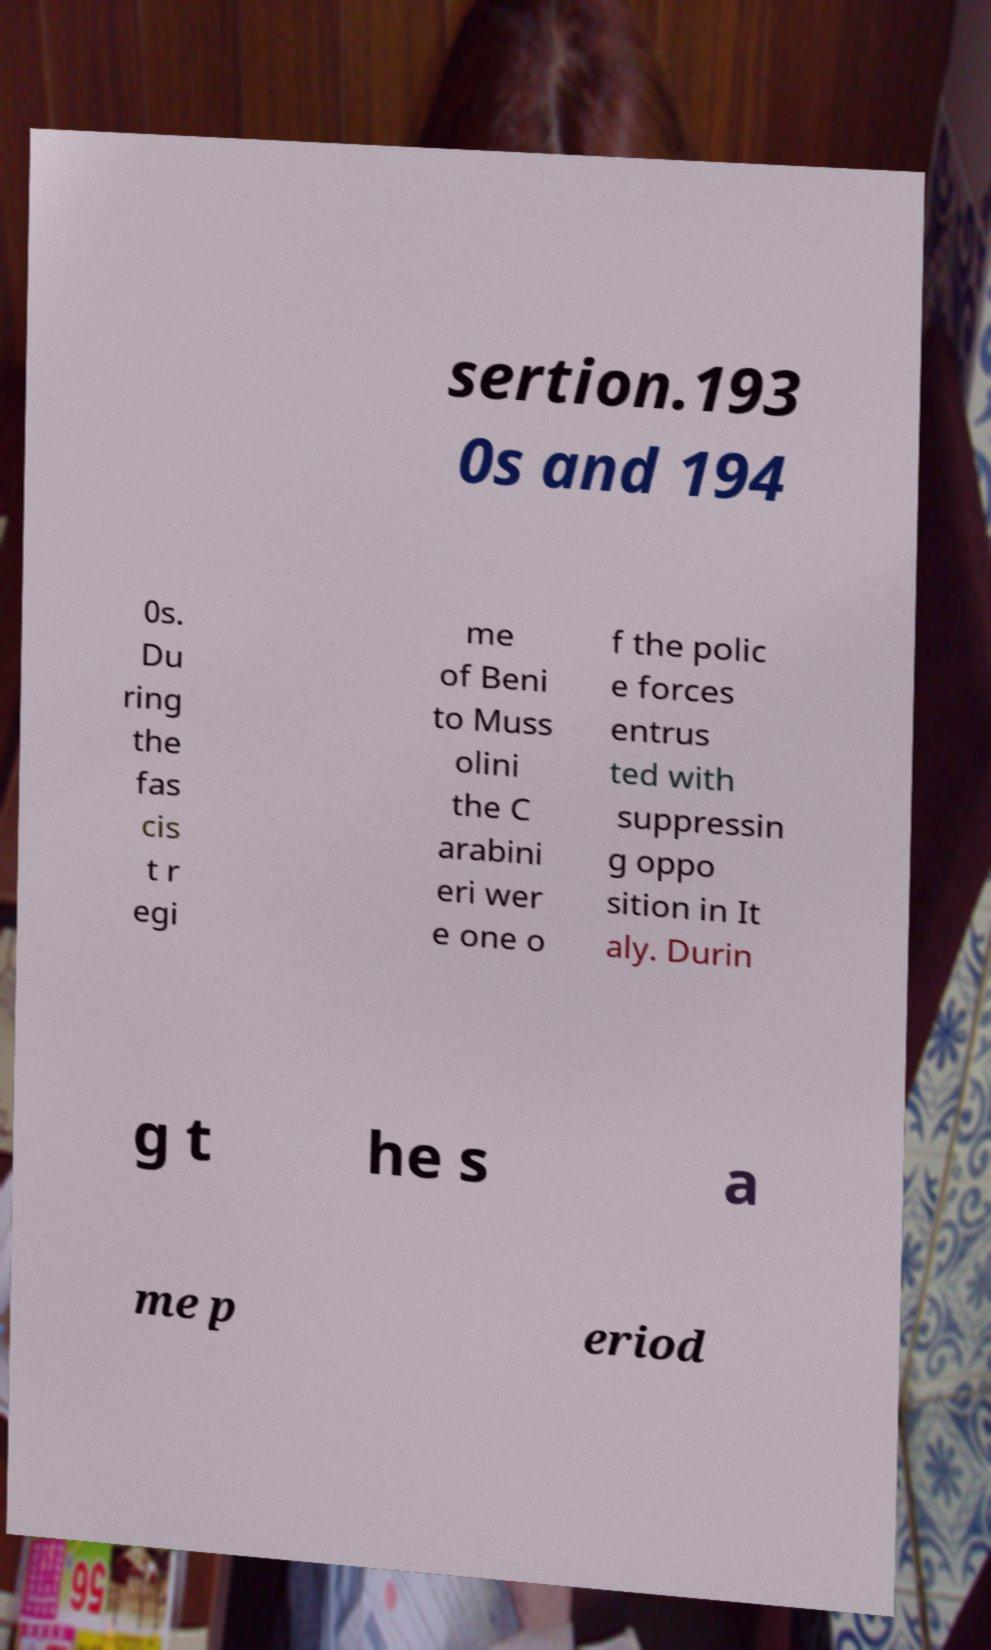Please read and relay the text visible in this image. What does it say? sertion.193 0s and 194 0s. Du ring the fas cis t r egi me of Beni to Muss olini the C arabini eri wer e one o f the polic e forces entrus ted with suppressin g oppo sition in It aly. Durin g t he s a me p eriod 